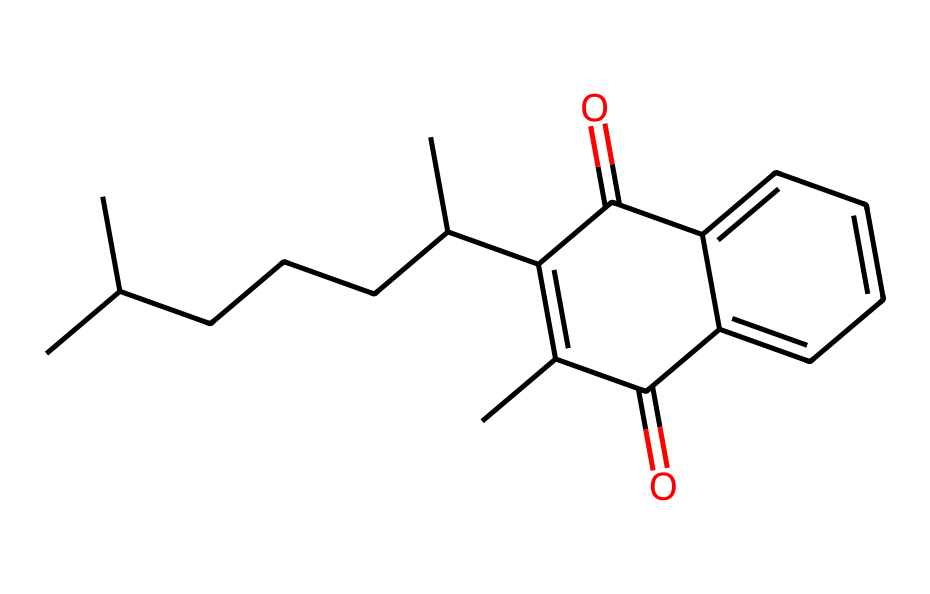What is the total number of carbon atoms in this vitamin K structure? By analyzing the SMILES representation, we can count all the 'C' characters, which represent carbon atoms. The total count here adds up to 20.
Answer: 20 How many rings are present in the chemical structure? Observing the structure and noting the connections, we can identify that there are two distinct ring systems formed due to the cyclic connections in the compound.
Answer: 2 What is the primary functional group indicated in this vitamin K representation? The chemical structure contains carbonyl groups (C=O) as part of its structure. This is evident from the presence of '=' signs in the SMILES that indicate double bonds, specifically at the two carbonyl groups.
Answer: carbonyl What type of compound does this structure represent? This vitamin K derivative has a complex structure characteristic of vitamins, particularly the phylloquinone type, which is associated with coagulation and also affects cardiovascular health.
Answer: vitamin K What structural feature suggests this compound has a role in cardiovascular health? The presence of the carbonyl groups in the structure indicates that vitamin K can interact with proteins involved in blood coagulation, potentially influencing cardiovascular functions.
Answer: carbonyl groups Which part of this chemical structure is primarily responsible for its solubility in fats? The long hydrocarbon chains and the cyclic structures increase lipophilicity, indicating that this vitamin K derivative is primarily fat-soluble due to its structure.
Answer: hydrocarbon chains 